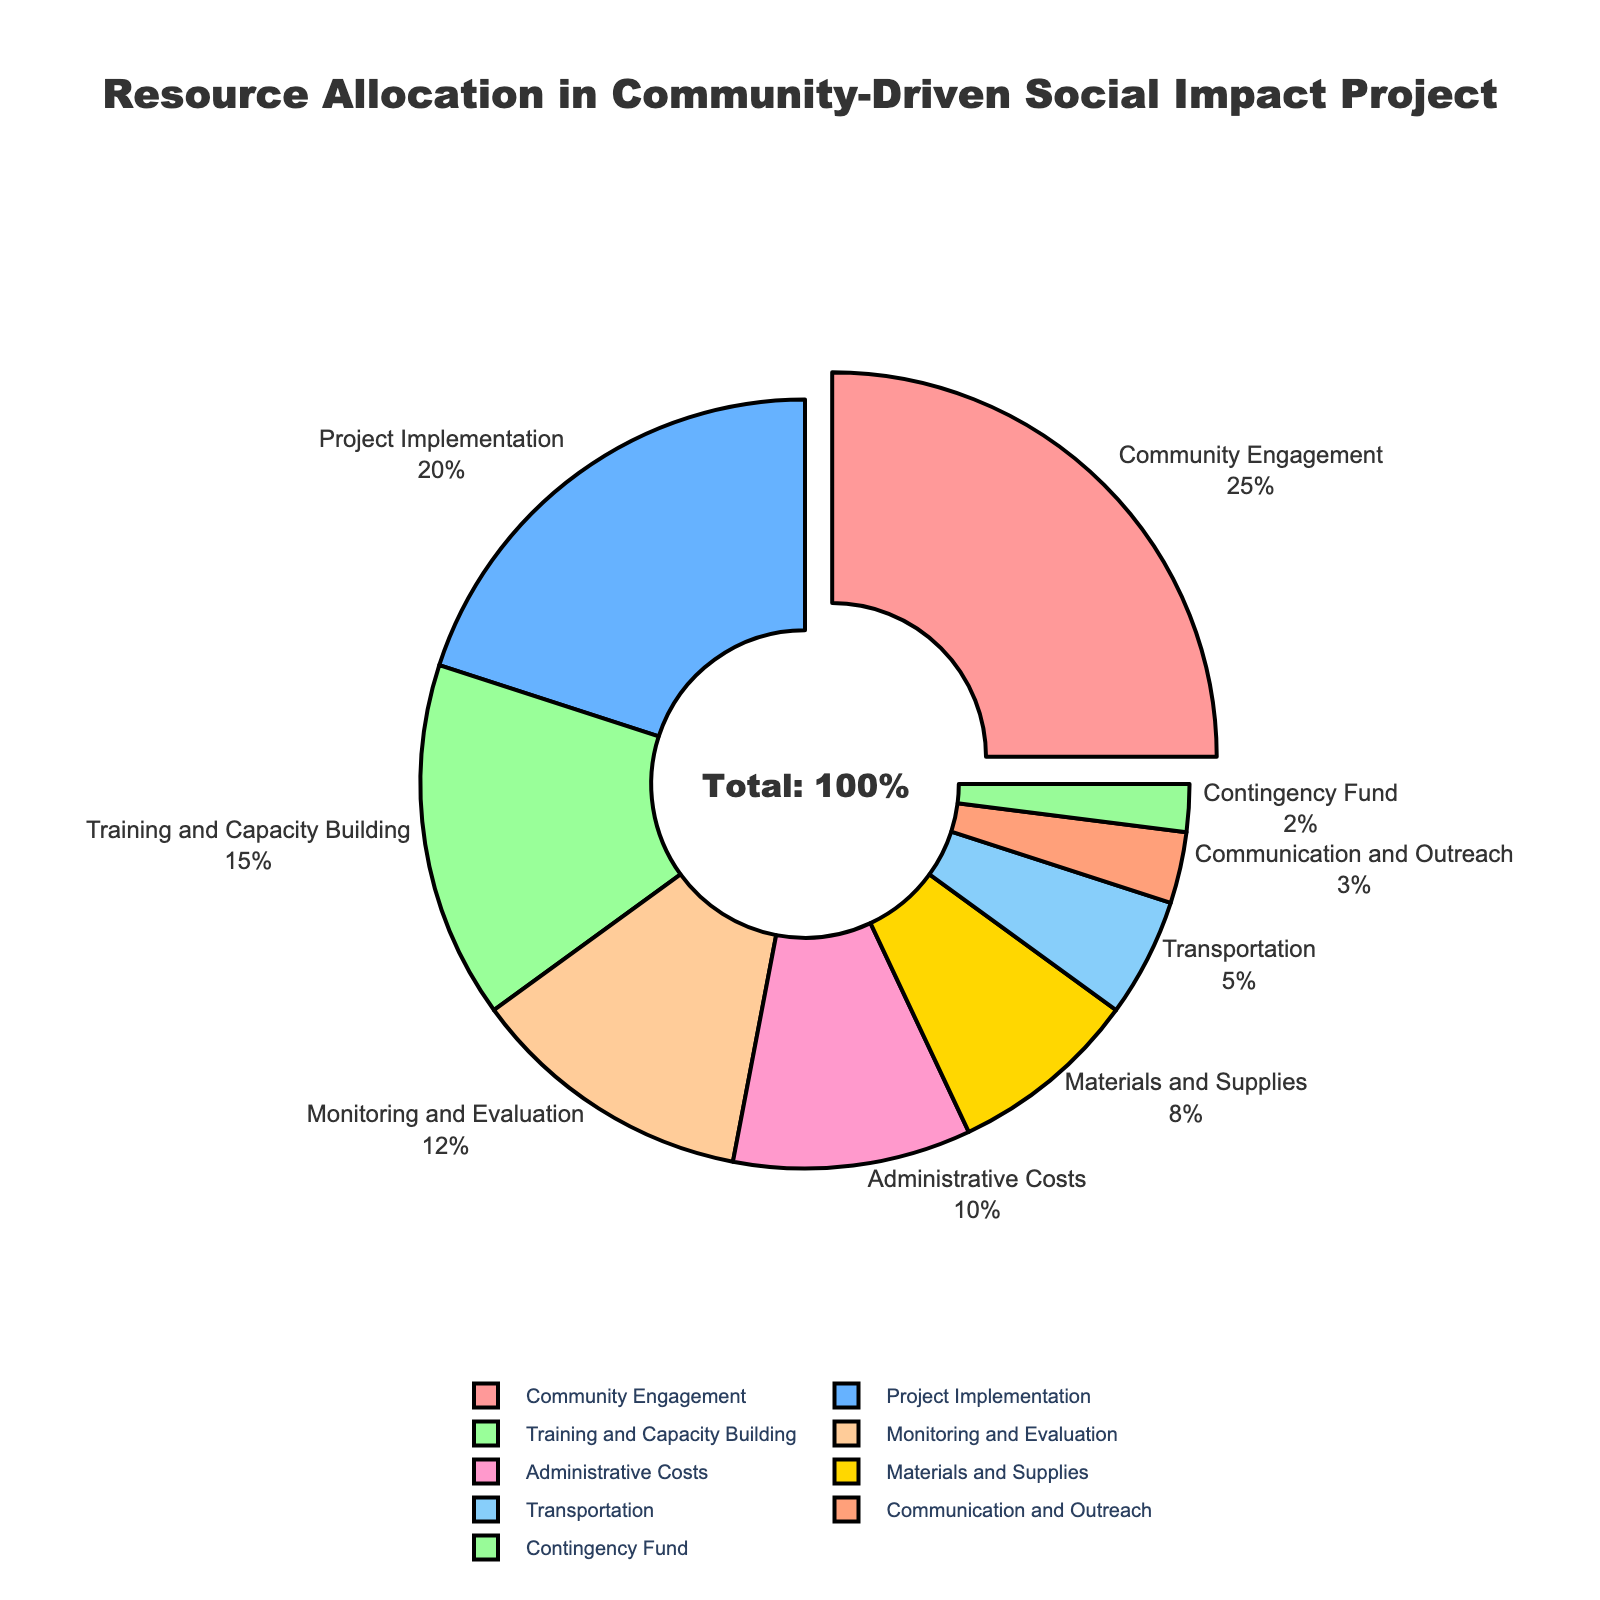What category receives the largest portion of the resources? The category receiving the largest portion is indicated by the segment pulled out from the pie chart and is also labeled with its percentage.
Answer: Community Engagement How much more percentage is allocated to Community Engagement than to Training and Capacity Building? Subtract the percentage allocated to Training and Capacity Building (15%) from the percentage allocated to Community Engagement (25%).
Answer: 10% Which categories combined make up more than 50% of the total allocation? Sum the percentages of each category, starting from the largest. Community Engagement (25%) + Project Implementation (20%) + Training and Capacity Building (15%) equals 60%.
Answer: Community Engagement, Project Implementation, Training and Capacity Building Is the share allocated to Administrative Costs greater than Materials and Supplies? Compare the percentage allocated to Administrative Costs (10%) with that of Materials and Supplies (8%).
Answer: Yes What is the total percentage allocated to Monitoring and Evaluation and Transportation combined? Add the percentages of Monitoring and Evaluation (12%) and Transportation (5%).
Answer: 17% Which category is allocated the smallest percentage of resources? The smallest portion can be identified by looking at the smallest segment in the pie chart and its corresponding percentage label.
Answer: Contingency Fund What's the percentage difference between Training and Capacity Building and Communication and Outreach? Subtract the percentage allocated to Communication and Outreach (3%) from that of Training and Capacity Building (15%).
Answer: 12% How does the allocation for Project Implementation compare to Monitoring and Evaluation? Compare the percentages allocated for Project Implementation (20%) and Monitoring and Evaluation (12%).
Answer: Project Implementation has a higher allocation What categories receive less than 10% of the total allocation each? Identify the segments that are smaller than 10%: Materials and Supplies (8%), Transportation (5%), Communication and Outreach (3%), and Contingency Fund (2%).
Answer: Materials and Supplies, Transportation, Communication and Outreach, Contingency Fund What is the combined percentage of the top three categories in terms of resource allocation? Sum the percentages of the top three categories: Community Engagement (25%), Project Implementation (20%), and Training and Capacity Building (15%).
Answer: 60% 